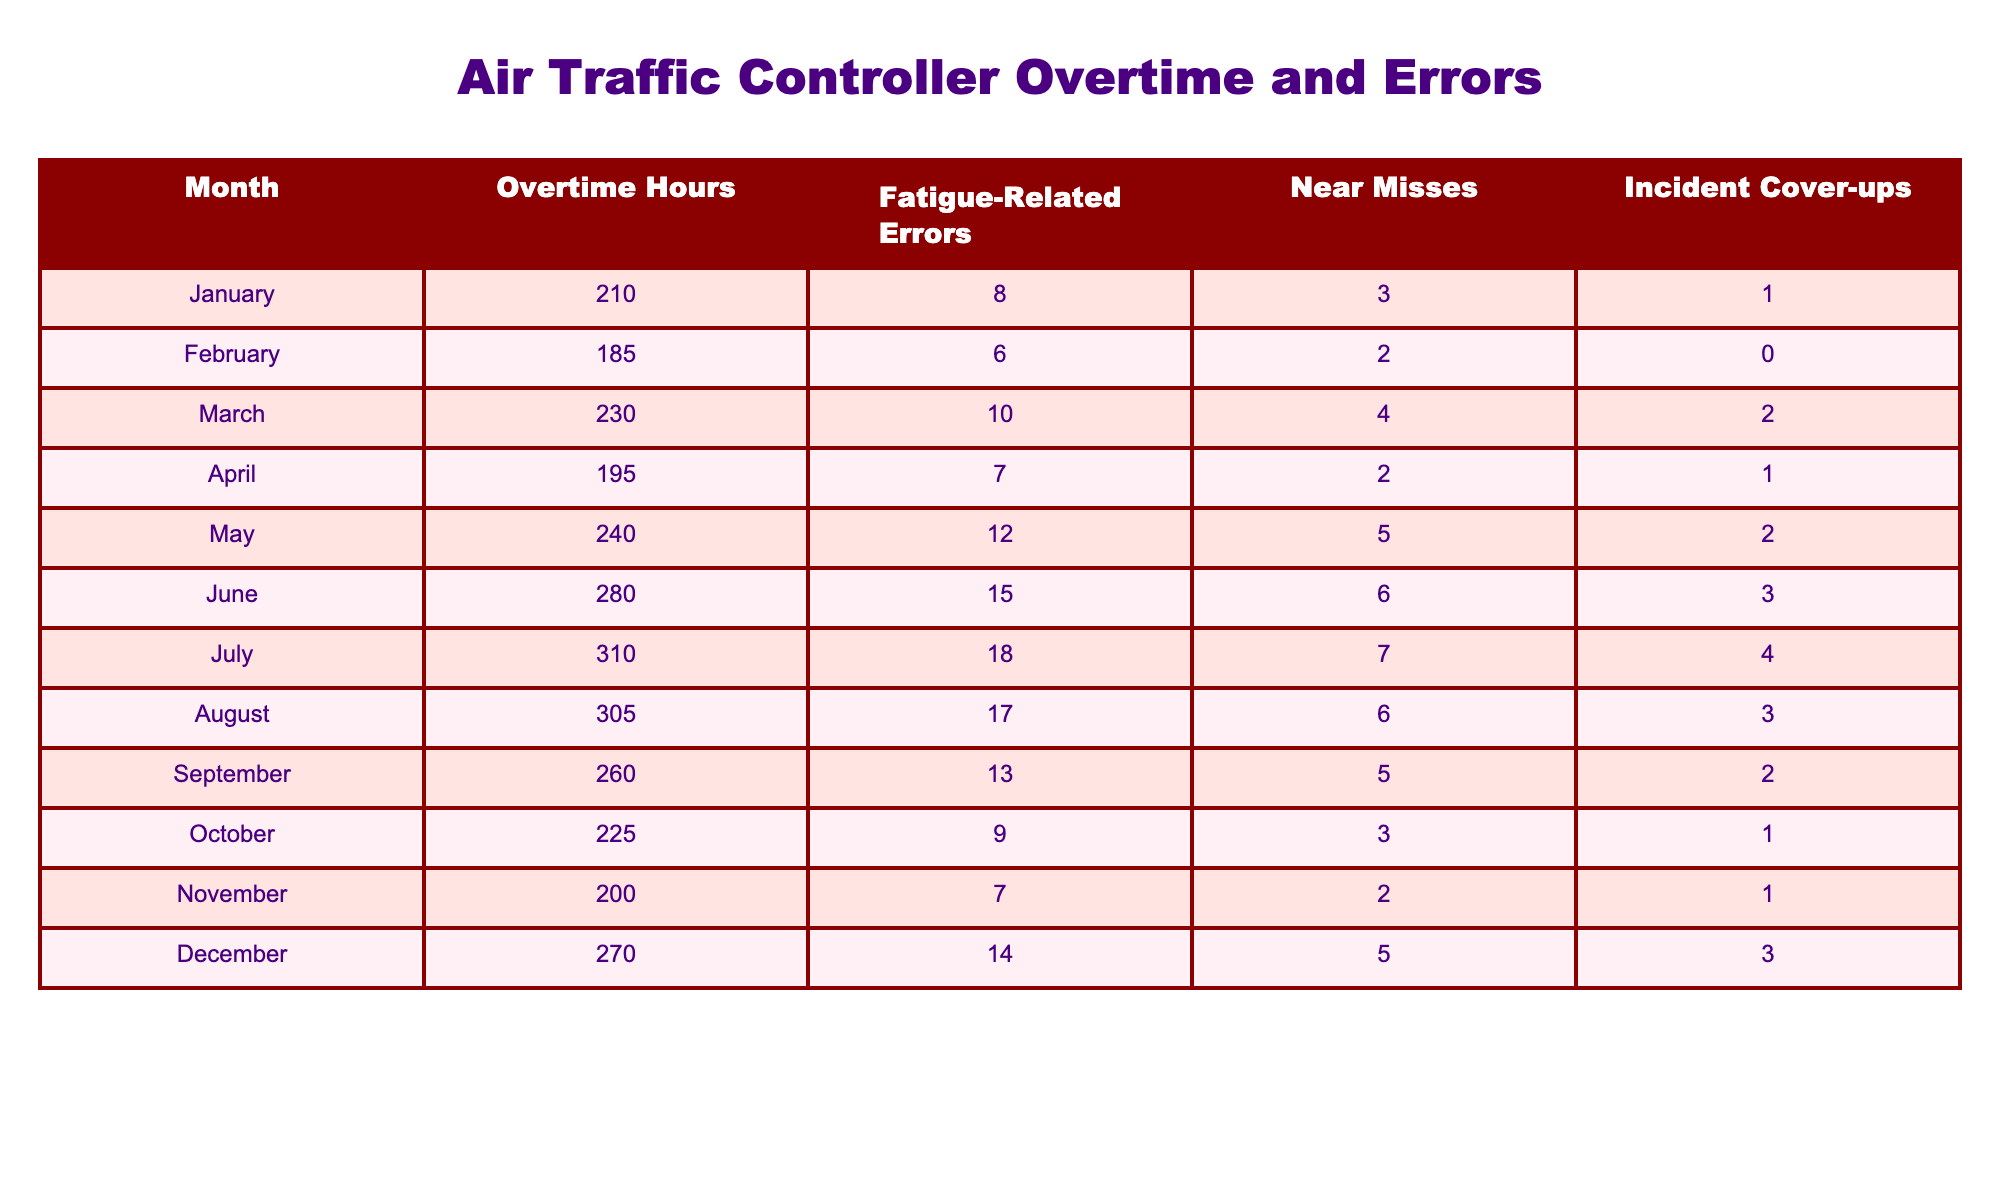What's the month with the highest number of overtime hours? Looking through the table, July shows the highest reported overtime hours at 310.
Answer: July How many fatigue-related errors occurred in June? Referring to the table, June has recorded 15 fatigue-related errors.
Answer: 15 What is the total number of fatigue-related errors for the entire year? By summing all monthly errors: 8 + 6 + 10 + 7 + 12 + 15 + 18 + 17 + 13 + 9 + 7 + 14 =  99 fatigue-related errors for the year.
Answer: 99 Which month had a higher incidence of near misses, May or April? May has 5 near misses while April has 2. Therefore, May had more near misses than April.
Answer: May Is it true that more than 20 fatigue-related errors occurred in the last quarter (October to December)? Totaling the errors from October (9), November (7), and December (14), we get 30 errors, which is more than 20.
Answer: Yes Calculate the average number of incident cover-ups per month. By adding the incident cover-ups: 1 + 0 + 2 + 1 + 2 + 3 + 4 + 3 + 2 + 1 + 1 + 3 = 23 and then divide by the 12 months: 23/12 = 1.92, which rounds to approximately 2.
Answer: 2 Which month saw a decrease in both overtime hours and fatigue-related errors compared to the previous month? Comparing the data, October (225 hours and 9 errors) decreased from September (260 hours and 13 errors).
Answer: October Identify the month with the least number of incident cover-ups. February has recorded 0 incident cover-ups, which is the lowest number.
Answer: February What is the difference in fatigue-related errors between the month with the most errors and the month with the least errors? May has the most errors with 12, and February has the least with 6. The difference is 12 - 6 = 6.
Answer: 6 In which month was the ratio of overtime hours to fatigue-related errors the highest? Examining the ratios, July has 310 hours and 18 errors (17.22), which is the highest ratio compared to other months.
Answer: July 